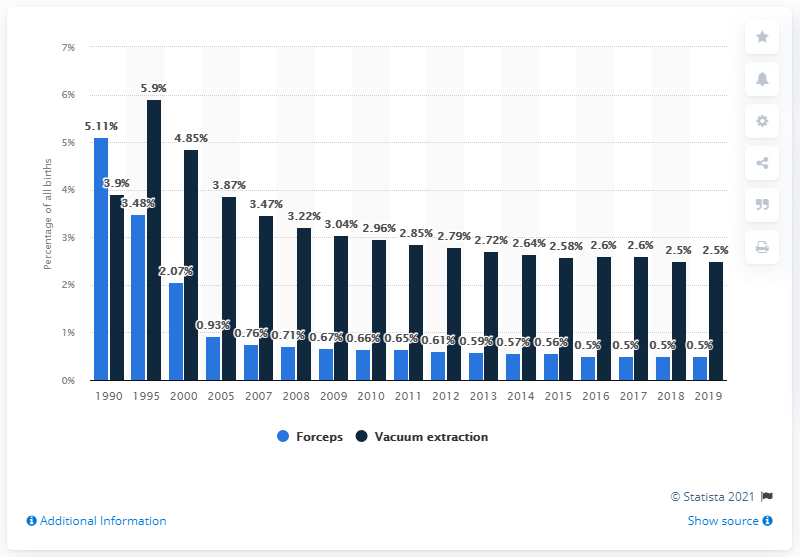Point out several critical features in this image. In 2019, approximately 0.5% of births were delivered using forceps. 